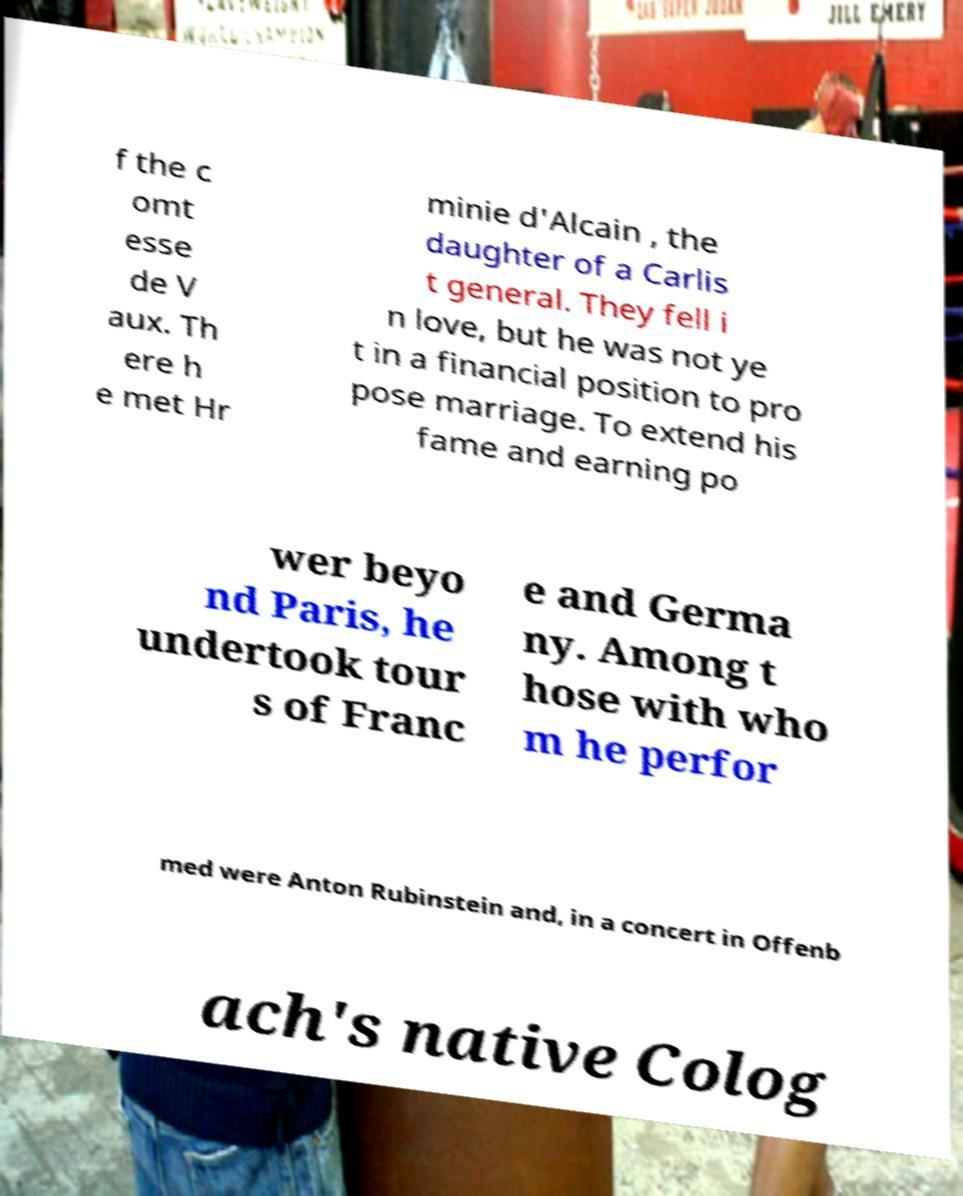Can you read and provide the text displayed in the image?This photo seems to have some interesting text. Can you extract and type it out for me? f the c omt esse de V aux. Th ere h e met Hr minie d'Alcain , the daughter of a Carlis t general. They fell i n love, but he was not ye t in a financial position to pro pose marriage. To extend his fame and earning po wer beyo nd Paris, he undertook tour s of Franc e and Germa ny. Among t hose with who m he perfor med were Anton Rubinstein and, in a concert in Offenb ach's native Colog 